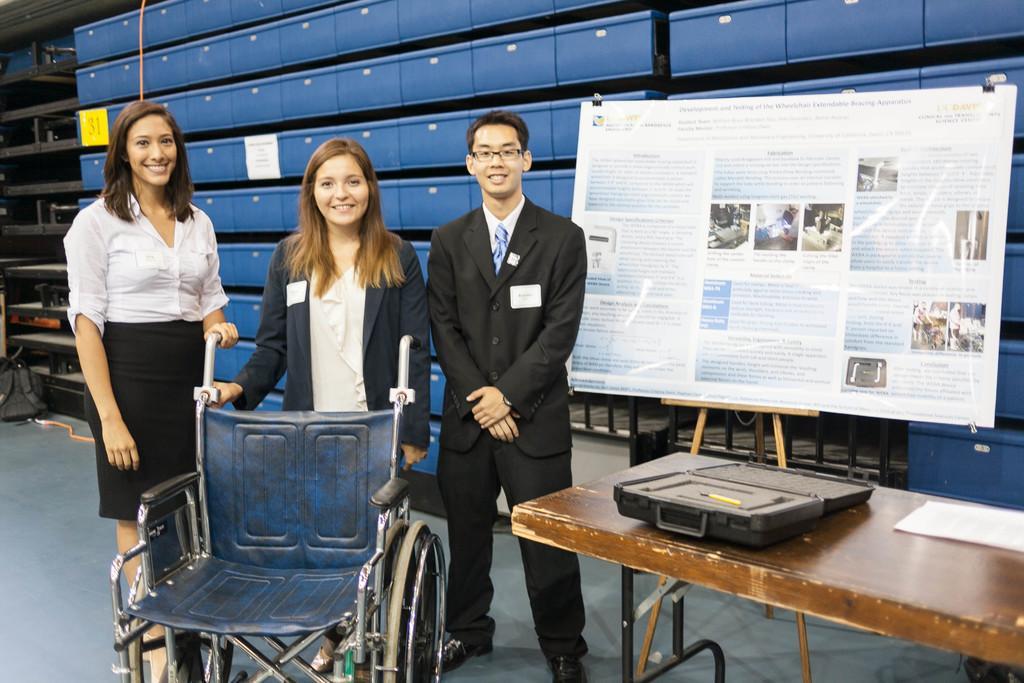Please provide a concise description of this image. On the background of the picture we can see lockers. This is a board and we can see a poster with clips over here. This is a table. this is a wheelchair. Behind to it there are three persons standing and holding a smile on their faces. 